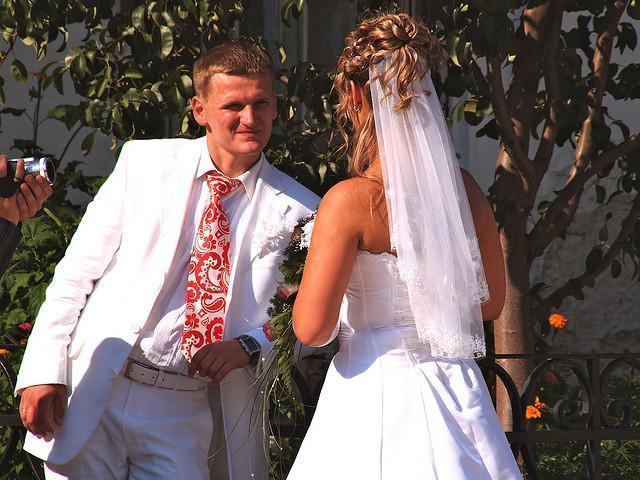What life event are they in the middle of celebrating?
Select the correct answer and articulate reasoning with the following format: 'Answer: answer
Rationale: rationale.'
Options: Anniversary, graduation, marriage, pregnancy. Answer: marriage.
Rationale: She is wearing a white gown and veil. a white gown and veil are used for weddings. 